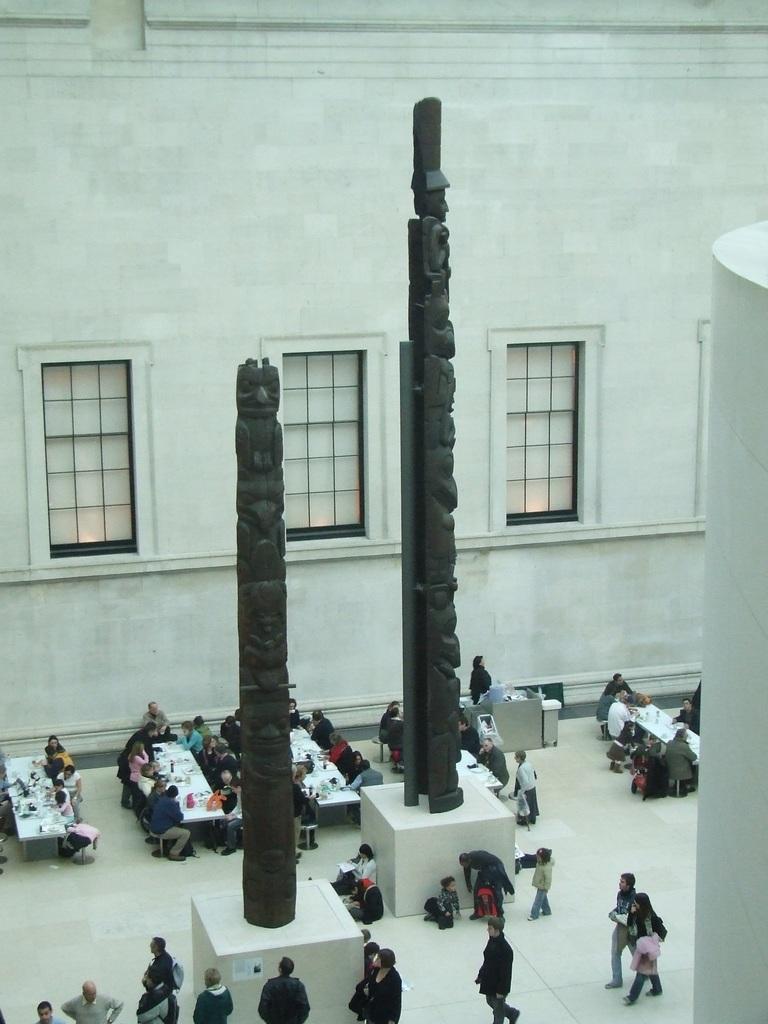Can you describe this image briefly? This picture shows an inner view of a hall and we see few windows on the wall and we see few people seated and we see few tables and few people walking on the side and we see couple of statues. 